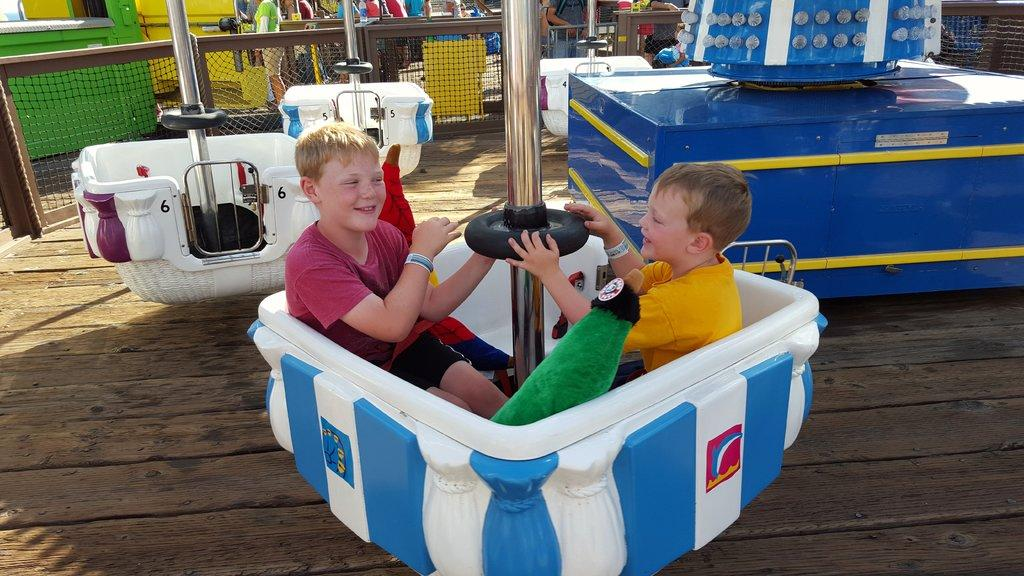How many children are in the image? There are two children in the image. What are the children doing in the image? The children are in an exhibition ride. What can be seen in the foreground of the image? There is a metal grill fence in the image. What is visible in the background of the image? There are people in the background of the image. What is the value of the gold fang in the image? There is no gold fang present in the image, so it is not possible to determine its value. 